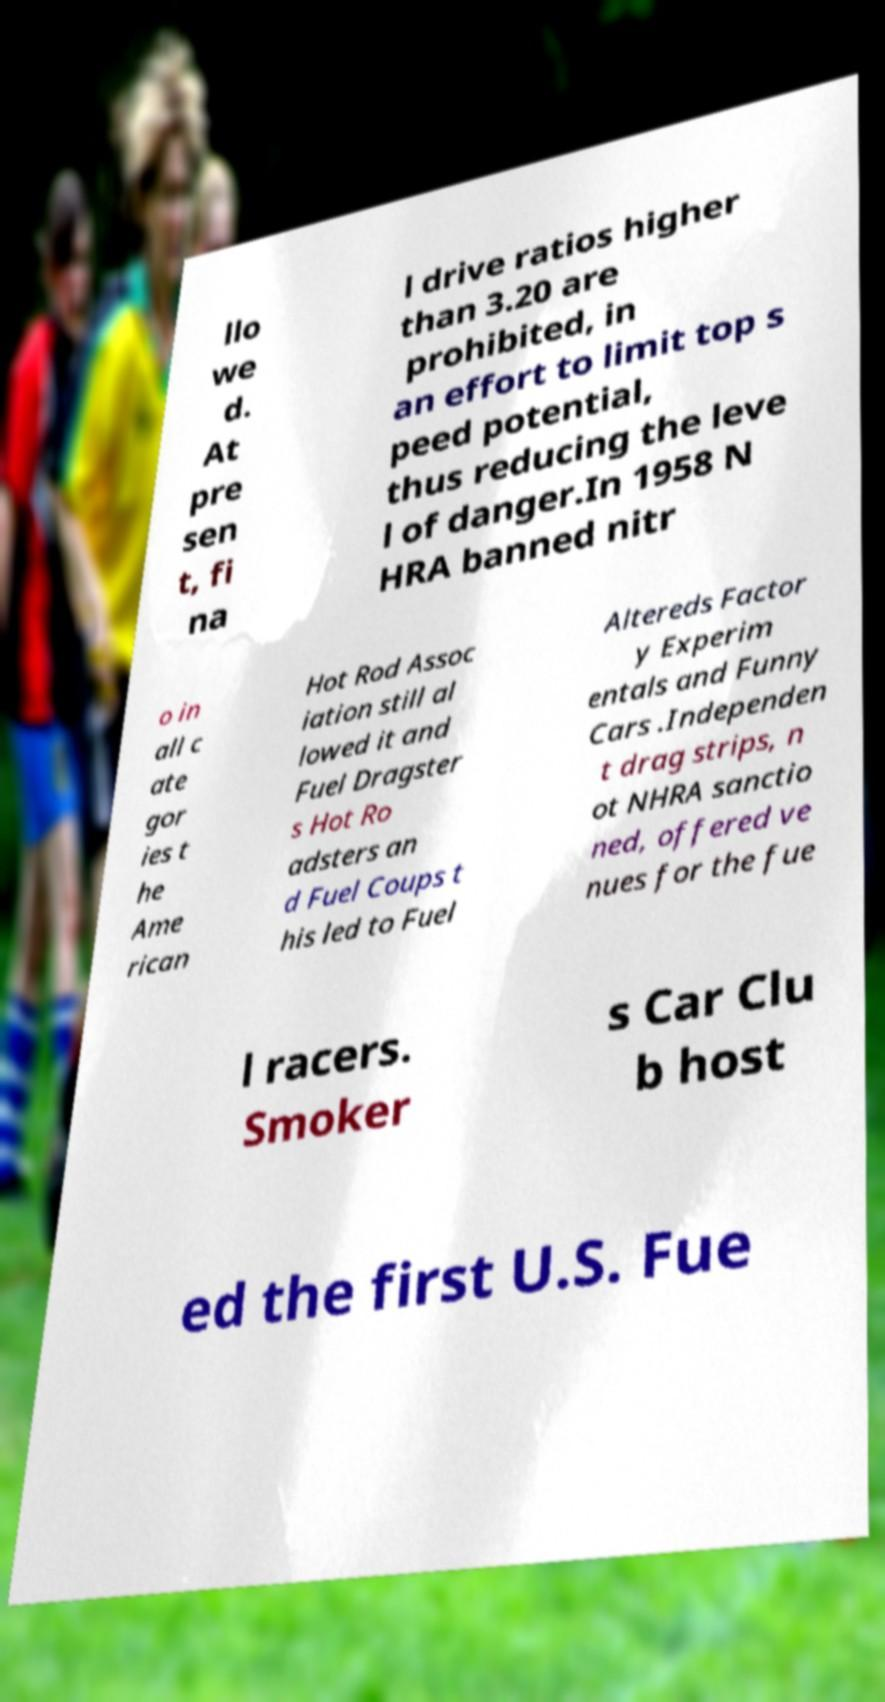Could you assist in decoding the text presented in this image and type it out clearly? llo we d. At pre sen t, fi na l drive ratios higher than 3.20 are prohibited, in an effort to limit top s peed potential, thus reducing the leve l of danger.In 1958 N HRA banned nitr o in all c ate gor ies t he Ame rican Hot Rod Assoc iation still al lowed it and Fuel Dragster s Hot Ro adsters an d Fuel Coups t his led to Fuel Altereds Factor y Experim entals and Funny Cars .Independen t drag strips, n ot NHRA sanctio ned, offered ve nues for the fue l racers. Smoker s Car Clu b host ed the first U.S. Fue 